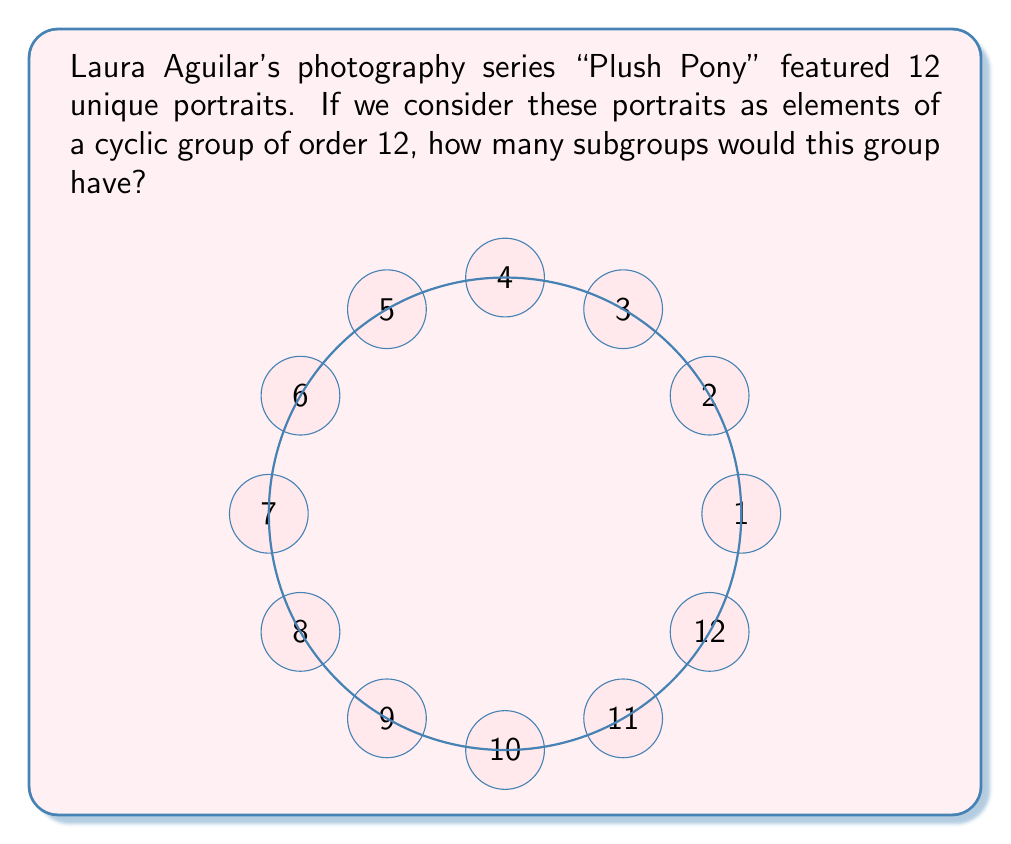Give your solution to this math problem. Let's approach this step-by-step:

1) First, recall that in a cyclic group of order $n$, the number of subgroups is equal to the number of divisors of $n$.

2) In this case, $n = 12$.

3) To find the divisors of 12, let's factor it:
   $12 = 2^2 \times 3$

4) To find all divisors, we consider all combinations of these prime factors:
   $1 = 2^0 \times 3^0$
   $2 = 2^1 \times 3^0$
   $3 = 2^0 \times 3^1$
   $4 = 2^2 \times 3^0$
   $6 = 2^1 \times 3^1$
   $12 = 2^2 \times 3^1$

5) Count the number of divisors: there are 6 divisors of 12.

6) Therefore, the cyclic group of order 12 has 6 subgroups.

These subgroups correspond to:
- The trivial subgroup $\{e\}$
- The subgroup of order 2
- The subgroup of order 3
- The subgroup of order 4
- The subgroup of order 6
- The entire group itself
Answer: 6 subgroups 